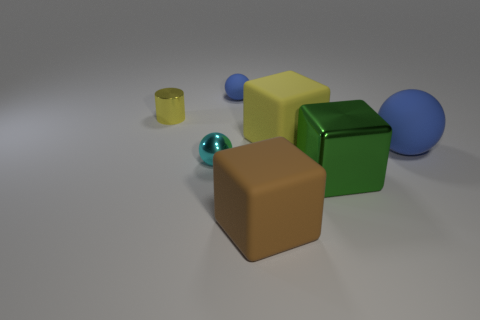Add 1 tiny blue spheres. How many objects exist? 8 Subtract all spheres. How many objects are left? 4 Add 2 blue things. How many blue things are left? 4 Add 1 tiny gray matte cylinders. How many tiny gray matte cylinders exist? 1 Subtract 1 blue balls. How many objects are left? 6 Subtract all matte balls. Subtract all large shiny things. How many objects are left? 4 